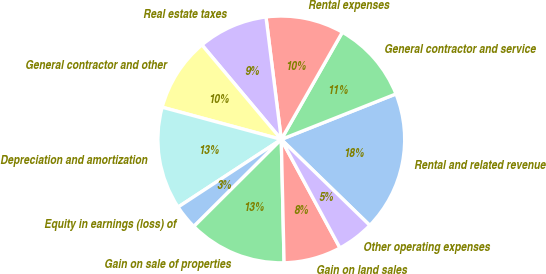<chart> <loc_0><loc_0><loc_500><loc_500><pie_chart><fcel>Rental and related revenue<fcel>General contractor and service<fcel>Rental expenses<fcel>Real estate taxes<fcel>General contractor and other<fcel>Depreciation and amortization<fcel>Equity in earnings (loss) of<fcel>Gain on sale of properties<fcel>Gain on land sales<fcel>Other operating expenses<nl><fcel>18.28%<fcel>10.75%<fcel>10.22%<fcel>9.14%<fcel>9.68%<fcel>13.44%<fcel>3.23%<fcel>12.9%<fcel>7.53%<fcel>4.84%<nl></chart> 